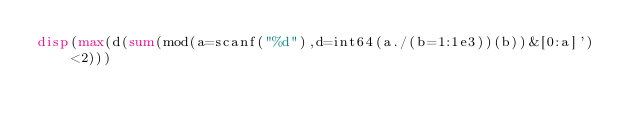Convert code to text. <code><loc_0><loc_0><loc_500><loc_500><_Octave_>disp(max(d(sum(mod(a=scanf("%d"),d=int64(a./(b=1:1e3))(b))&[0:a]')<2)))</code> 